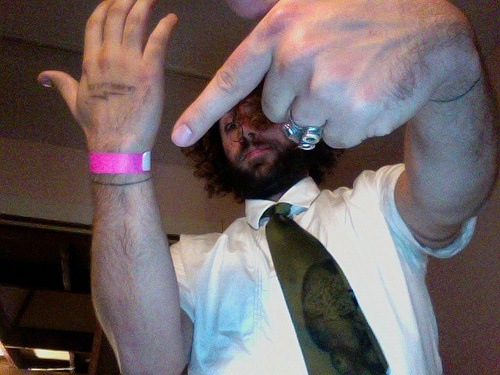Describe the objects in this image and their specific colors. I can see people in black, darkgray, gray, and lightgray tones and tie in black, darkgreen, and gray tones in this image. 